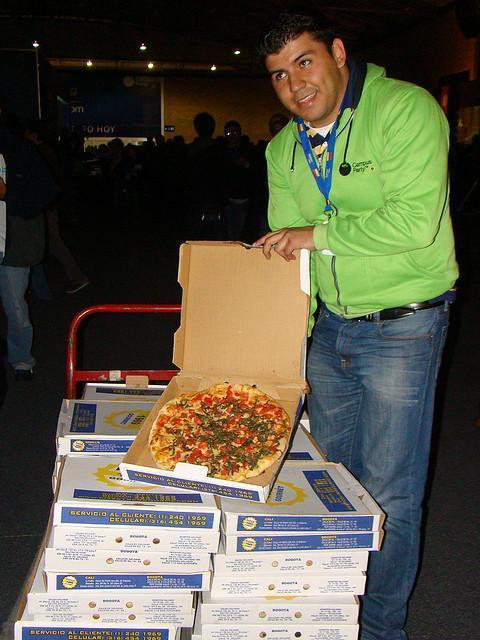How many people are visible?
Give a very brief answer. 3. 